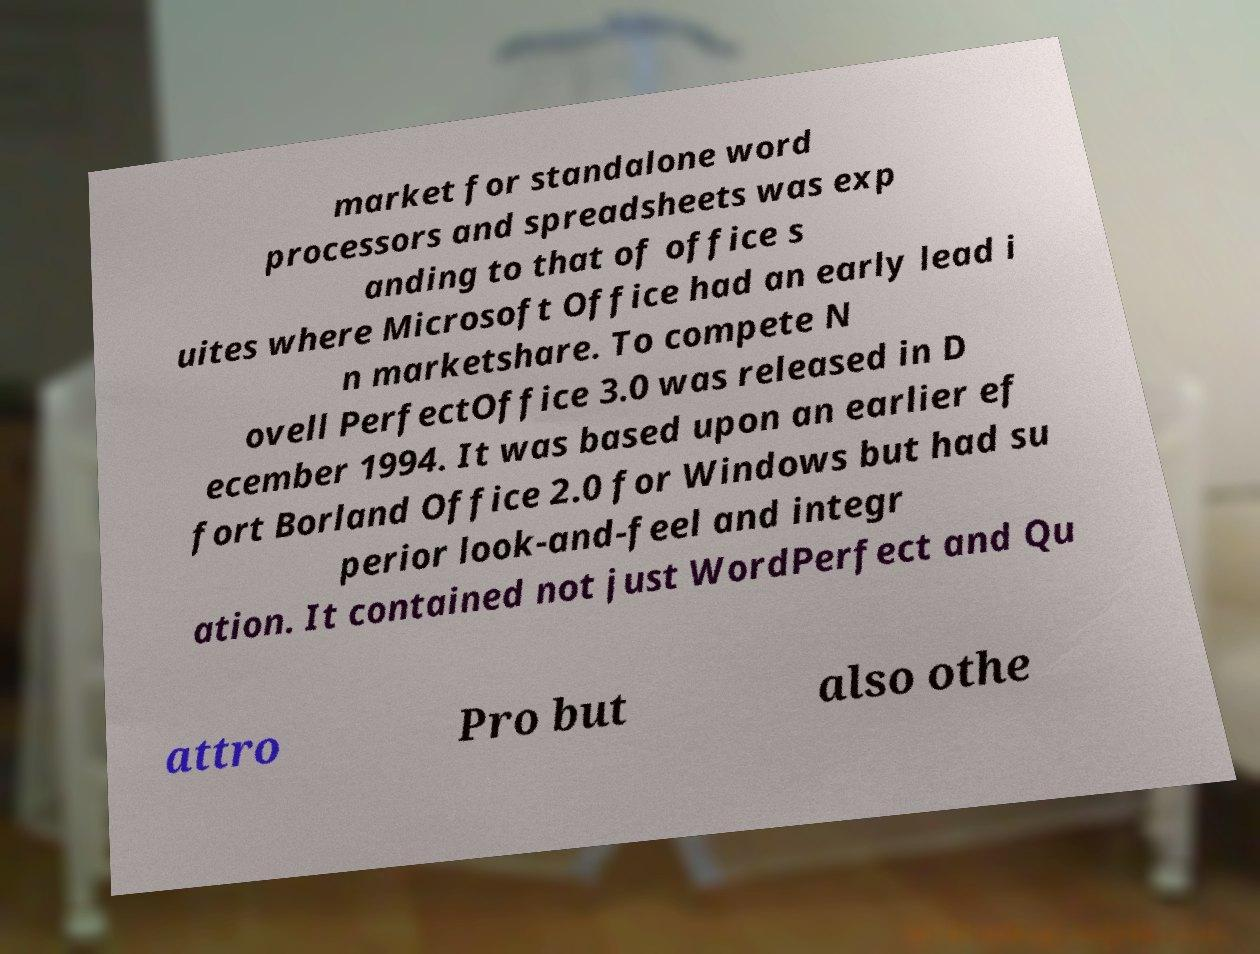I need the written content from this picture converted into text. Can you do that? market for standalone word processors and spreadsheets was exp anding to that of office s uites where Microsoft Office had an early lead i n marketshare. To compete N ovell PerfectOffice 3.0 was released in D ecember 1994. It was based upon an earlier ef fort Borland Office 2.0 for Windows but had su perior look-and-feel and integr ation. It contained not just WordPerfect and Qu attro Pro but also othe 